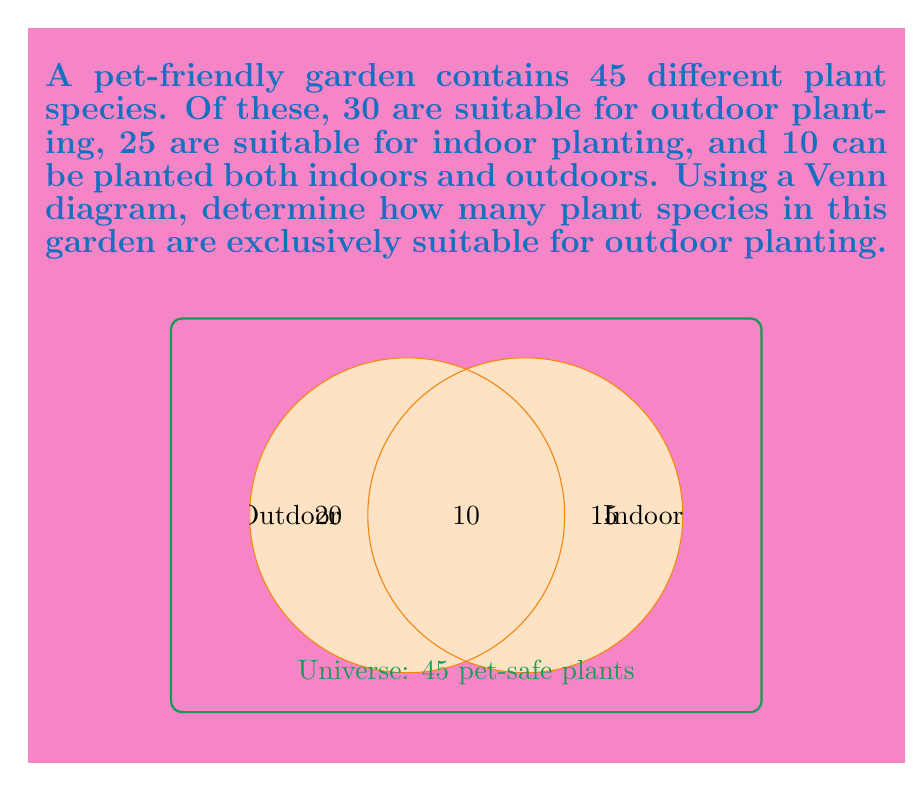Teach me how to tackle this problem. Let's approach this step-by-step using set theory and the given Venn diagram:

1) Let $A$ be the set of outdoor plants and $B$ be the set of indoor plants.

2) We're given:
   - Total number of plants: $n(A \cup B) = 45$
   - Number of outdoor plants: $n(A) = 30$
   - Number of indoor plants: $n(B) = 25$
   - Number of plants suitable for both: $n(A \cap B) = 10$

3) We need to find $n(A - B)$, which represents plants exclusively suitable for outdoors.

4) From the addition principle of sets:
   $n(A \cup B) = n(A) + n(B) - n(A \cap B)$

5) Substituting the known values:
   $45 = 30 + 25 - 10$
   $45 = 45$ (This confirms our given information is consistent)

6) To find $n(A - B)$, we can use:
   $n(A - B) = n(A) - n(A \cap B)$

7) Substituting the values:
   $n(A - B) = 30 - 10 = 20$

Therefore, 20 plant species in this garden are exclusively suitable for outdoor planting.
Answer: 20 plant species 